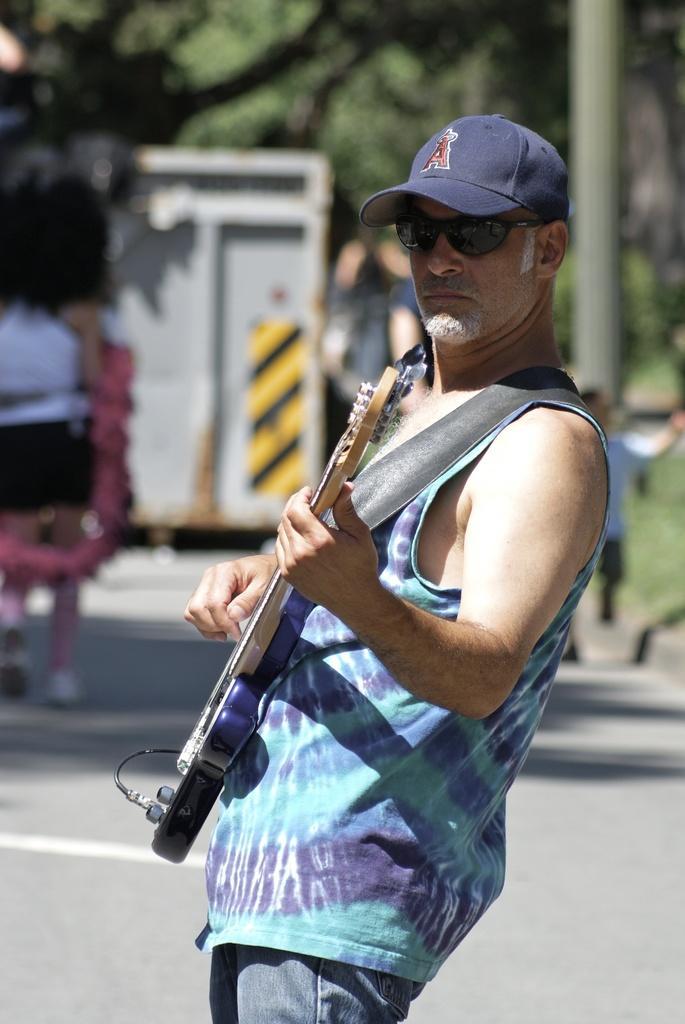Can you describe this image briefly? In this image I can see a man is standing and playing the guitar, he wore blue color t-shirt and a cap. This is the road. 